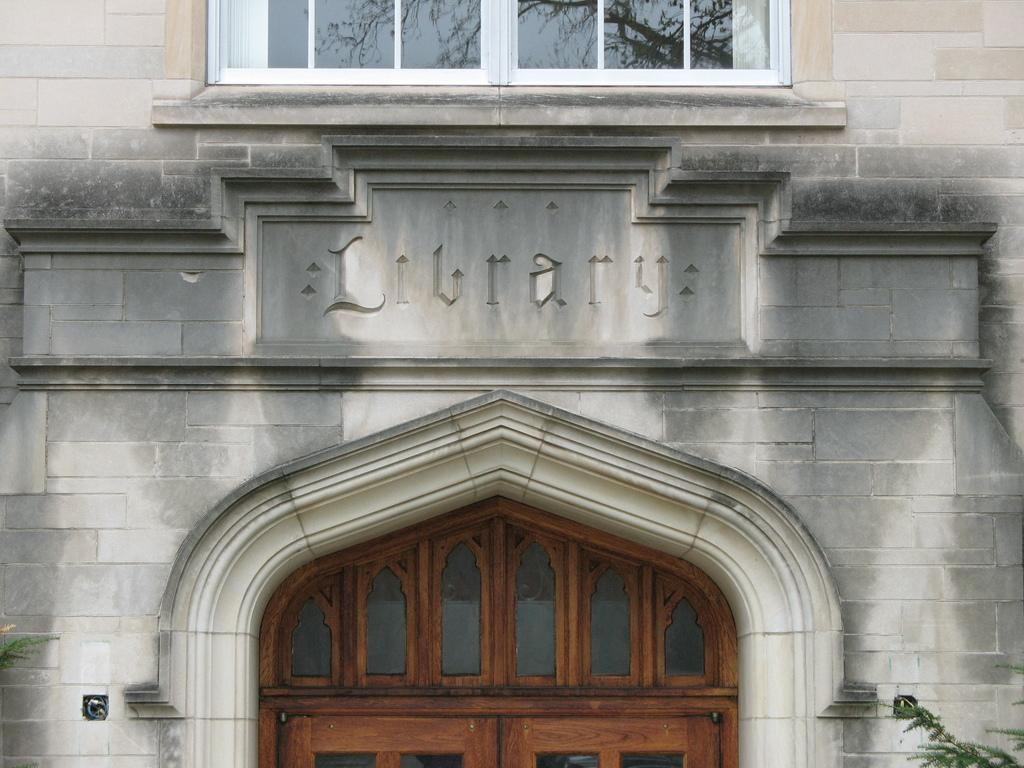What type of structure is visible in the image? There is a building in the image. Are there any openings in the building? Yes, there is a window and a door visible in the image. What can be seen in the bottom right corner of the image? Leaves are visible in the right bottom of the image. Are there any leaves present on the left side of the image? Yes, leaves are present on the left side of the image. What type of sack is being used to carry the trees in the image? There are no trees or sacks present in the image. What is the chance of winning a prize in the image? There is no mention of a prize or a chance to win in the image. 